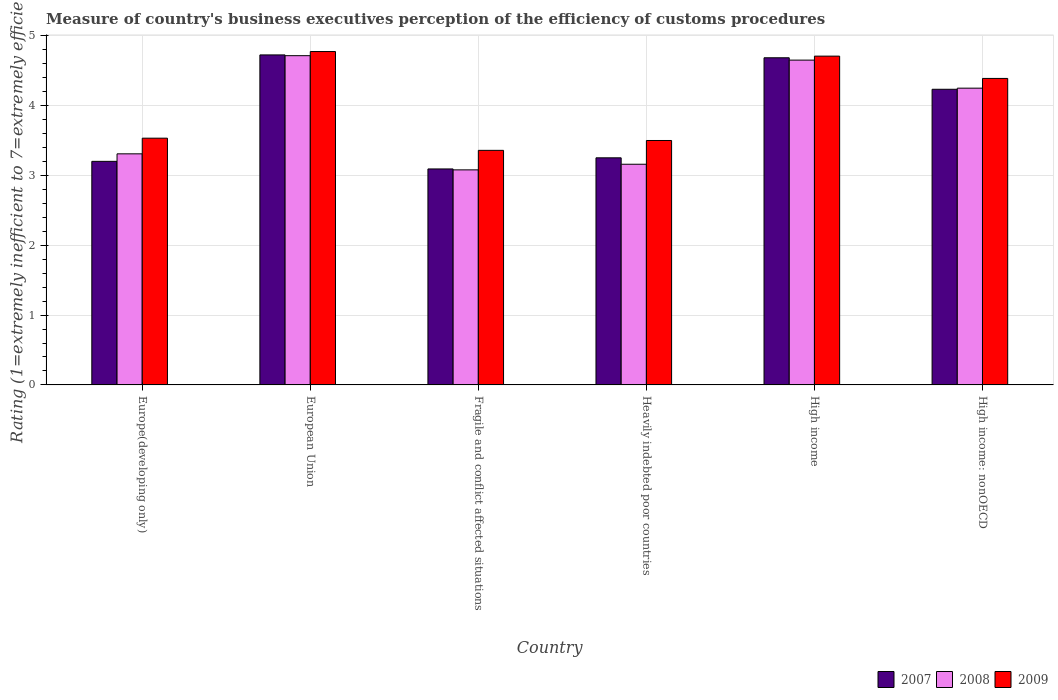How many groups of bars are there?
Make the answer very short. 6. Are the number of bars per tick equal to the number of legend labels?
Your answer should be very brief. Yes. Are the number of bars on each tick of the X-axis equal?
Provide a short and direct response. Yes. How many bars are there on the 4th tick from the right?
Make the answer very short. 3. What is the label of the 3rd group of bars from the left?
Offer a terse response. Fragile and conflict affected situations. In how many cases, is the number of bars for a given country not equal to the number of legend labels?
Keep it short and to the point. 0. What is the rating of the efficiency of customs procedure in 2009 in Europe(developing only)?
Provide a succinct answer. 3.53. Across all countries, what is the maximum rating of the efficiency of customs procedure in 2009?
Your answer should be compact. 4.77. Across all countries, what is the minimum rating of the efficiency of customs procedure in 2007?
Ensure brevity in your answer.  3.09. In which country was the rating of the efficiency of customs procedure in 2009 maximum?
Provide a succinct answer. European Union. In which country was the rating of the efficiency of customs procedure in 2009 minimum?
Give a very brief answer. Fragile and conflict affected situations. What is the total rating of the efficiency of customs procedure in 2007 in the graph?
Keep it short and to the point. 23.19. What is the difference between the rating of the efficiency of customs procedure in 2009 in Europe(developing only) and that in High income: nonOECD?
Provide a short and direct response. -0.86. What is the difference between the rating of the efficiency of customs procedure in 2009 in High income and the rating of the efficiency of customs procedure in 2007 in European Union?
Provide a succinct answer. -0.02. What is the average rating of the efficiency of customs procedure in 2007 per country?
Ensure brevity in your answer.  3.86. What is the difference between the rating of the efficiency of customs procedure of/in 2008 and rating of the efficiency of customs procedure of/in 2007 in High income: nonOECD?
Your answer should be very brief. 0.02. What is the ratio of the rating of the efficiency of customs procedure in 2008 in Europe(developing only) to that in European Union?
Provide a short and direct response. 0.7. Is the difference between the rating of the efficiency of customs procedure in 2008 in Europe(developing only) and Fragile and conflict affected situations greater than the difference between the rating of the efficiency of customs procedure in 2007 in Europe(developing only) and Fragile and conflict affected situations?
Make the answer very short. Yes. What is the difference between the highest and the second highest rating of the efficiency of customs procedure in 2007?
Make the answer very short. 0.04. What is the difference between the highest and the lowest rating of the efficiency of customs procedure in 2008?
Your response must be concise. 1.64. In how many countries, is the rating of the efficiency of customs procedure in 2009 greater than the average rating of the efficiency of customs procedure in 2009 taken over all countries?
Give a very brief answer. 3. What does the 2nd bar from the right in Fragile and conflict affected situations represents?
Offer a terse response. 2008. Is it the case that in every country, the sum of the rating of the efficiency of customs procedure in 2008 and rating of the efficiency of customs procedure in 2009 is greater than the rating of the efficiency of customs procedure in 2007?
Your answer should be compact. Yes. How many bars are there?
Keep it short and to the point. 18. Are all the bars in the graph horizontal?
Offer a terse response. No. What is the difference between two consecutive major ticks on the Y-axis?
Provide a short and direct response. 1. Does the graph contain any zero values?
Provide a succinct answer. No. Does the graph contain grids?
Give a very brief answer. Yes. How many legend labels are there?
Provide a short and direct response. 3. How are the legend labels stacked?
Provide a succinct answer. Horizontal. What is the title of the graph?
Make the answer very short. Measure of country's business executives perception of the efficiency of customs procedures. What is the label or title of the X-axis?
Your response must be concise. Country. What is the label or title of the Y-axis?
Offer a terse response. Rating (1=extremely inefficient to 7=extremely efficient). What is the Rating (1=extremely inefficient to 7=extremely efficient) of 2007 in Europe(developing only)?
Give a very brief answer. 3.2. What is the Rating (1=extremely inefficient to 7=extremely efficient) of 2008 in Europe(developing only)?
Make the answer very short. 3.31. What is the Rating (1=extremely inefficient to 7=extremely efficient) of 2009 in Europe(developing only)?
Provide a short and direct response. 3.53. What is the Rating (1=extremely inefficient to 7=extremely efficient) in 2007 in European Union?
Your answer should be very brief. 4.73. What is the Rating (1=extremely inefficient to 7=extremely efficient) of 2008 in European Union?
Give a very brief answer. 4.71. What is the Rating (1=extremely inefficient to 7=extremely efficient) of 2009 in European Union?
Make the answer very short. 4.77. What is the Rating (1=extremely inefficient to 7=extremely efficient) of 2007 in Fragile and conflict affected situations?
Your response must be concise. 3.09. What is the Rating (1=extremely inefficient to 7=extremely efficient) of 2008 in Fragile and conflict affected situations?
Ensure brevity in your answer.  3.08. What is the Rating (1=extremely inefficient to 7=extremely efficient) of 2009 in Fragile and conflict affected situations?
Your answer should be very brief. 3.36. What is the Rating (1=extremely inefficient to 7=extremely efficient) in 2007 in Heavily indebted poor countries?
Make the answer very short. 3.25. What is the Rating (1=extremely inefficient to 7=extremely efficient) in 2008 in Heavily indebted poor countries?
Offer a terse response. 3.16. What is the Rating (1=extremely inefficient to 7=extremely efficient) in 2009 in Heavily indebted poor countries?
Provide a short and direct response. 3.5. What is the Rating (1=extremely inefficient to 7=extremely efficient) of 2007 in High income?
Provide a succinct answer. 4.68. What is the Rating (1=extremely inefficient to 7=extremely efficient) of 2008 in High income?
Make the answer very short. 4.65. What is the Rating (1=extremely inefficient to 7=extremely efficient) of 2009 in High income?
Keep it short and to the point. 4.71. What is the Rating (1=extremely inefficient to 7=extremely efficient) in 2007 in High income: nonOECD?
Make the answer very short. 4.23. What is the Rating (1=extremely inefficient to 7=extremely efficient) in 2008 in High income: nonOECD?
Give a very brief answer. 4.25. What is the Rating (1=extremely inefficient to 7=extremely efficient) of 2009 in High income: nonOECD?
Make the answer very short. 4.39. Across all countries, what is the maximum Rating (1=extremely inefficient to 7=extremely efficient) of 2007?
Make the answer very short. 4.73. Across all countries, what is the maximum Rating (1=extremely inefficient to 7=extremely efficient) in 2008?
Your answer should be very brief. 4.71. Across all countries, what is the maximum Rating (1=extremely inefficient to 7=extremely efficient) of 2009?
Your response must be concise. 4.77. Across all countries, what is the minimum Rating (1=extremely inefficient to 7=extremely efficient) in 2007?
Keep it short and to the point. 3.09. Across all countries, what is the minimum Rating (1=extremely inefficient to 7=extremely efficient) of 2008?
Ensure brevity in your answer.  3.08. Across all countries, what is the minimum Rating (1=extremely inefficient to 7=extremely efficient) in 2009?
Give a very brief answer. 3.36. What is the total Rating (1=extremely inefficient to 7=extremely efficient) of 2007 in the graph?
Give a very brief answer. 23.19. What is the total Rating (1=extremely inefficient to 7=extremely efficient) of 2008 in the graph?
Your answer should be very brief. 23.16. What is the total Rating (1=extremely inefficient to 7=extremely efficient) of 2009 in the graph?
Offer a very short reply. 24.26. What is the difference between the Rating (1=extremely inefficient to 7=extremely efficient) of 2007 in Europe(developing only) and that in European Union?
Offer a terse response. -1.52. What is the difference between the Rating (1=extremely inefficient to 7=extremely efficient) of 2008 in Europe(developing only) and that in European Union?
Offer a terse response. -1.41. What is the difference between the Rating (1=extremely inefficient to 7=extremely efficient) in 2009 in Europe(developing only) and that in European Union?
Offer a terse response. -1.24. What is the difference between the Rating (1=extremely inefficient to 7=extremely efficient) in 2007 in Europe(developing only) and that in Fragile and conflict affected situations?
Offer a very short reply. 0.11. What is the difference between the Rating (1=extremely inefficient to 7=extremely efficient) of 2008 in Europe(developing only) and that in Fragile and conflict affected situations?
Provide a short and direct response. 0.23. What is the difference between the Rating (1=extremely inefficient to 7=extremely efficient) of 2009 in Europe(developing only) and that in Fragile and conflict affected situations?
Provide a short and direct response. 0.17. What is the difference between the Rating (1=extremely inefficient to 7=extremely efficient) of 2007 in Europe(developing only) and that in Heavily indebted poor countries?
Keep it short and to the point. -0.05. What is the difference between the Rating (1=extremely inefficient to 7=extremely efficient) in 2008 in Europe(developing only) and that in Heavily indebted poor countries?
Provide a short and direct response. 0.15. What is the difference between the Rating (1=extremely inefficient to 7=extremely efficient) in 2009 in Europe(developing only) and that in Heavily indebted poor countries?
Provide a short and direct response. 0.03. What is the difference between the Rating (1=extremely inefficient to 7=extremely efficient) of 2007 in Europe(developing only) and that in High income?
Give a very brief answer. -1.48. What is the difference between the Rating (1=extremely inefficient to 7=extremely efficient) in 2008 in Europe(developing only) and that in High income?
Offer a very short reply. -1.34. What is the difference between the Rating (1=extremely inefficient to 7=extremely efficient) of 2009 in Europe(developing only) and that in High income?
Your answer should be very brief. -1.18. What is the difference between the Rating (1=extremely inefficient to 7=extremely efficient) of 2007 in Europe(developing only) and that in High income: nonOECD?
Ensure brevity in your answer.  -1.03. What is the difference between the Rating (1=extremely inefficient to 7=extremely efficient) in 2008 in Europe(developing only) and that in High income: nonOECD?
Your answer should be very brief. -0.94. What is the difference between the Rating (1=extremely inefficient to 7=extremely efficient) of 2009 in Europe(developing only) and that in High income: nonOECD?
Make the answer very short. -0.86. What is the difference between the Rating (1=extremely inefficient to 7=extremely efficient) of 2007 in European Union and that in Fragile and conflict affected situations?
Provide a short and direct response. 1.63. What is the difference between the Rating (1=extremely inefficient to 7=extremely efficient) in 2008 in European Union and that in Fragile and conflict affected situations?
Your answer should be compact. 1.64. What is the difference between the Rating (1=extremely inefficient to 7=extremely efficient) in 2009 in European Union and that in Fragile and conflict affected situations?
Your answer should be compact. 1.41. What is the difference between the Rating (1=extremely inefficient to 7=extremely efficient) of 2007 in European Union and that in Heavily indebted poor countries?
Your answer should be compact. 1.47. What is the difference between the Rating (1=extremely inefficient to 7=extremely efficient) of 2008 in European Union and that in Heavily indebted poor countries?
Your answer should be very brief. 1.55. What is the difference between the Rating (1=extremely inefficient to 7=extremely efficient) in 2009 in European Union and that in Heavily indebted poor countries?
Your response must be concise. 1.27. What is the difference between the Rating (1=extremely inefficient to 7=extremely efficient) in 2007 in European Union and that in High income?
Your answer should be very brief. 0.04. What is the difference between the Rating (1=extremely inefficient to 7=extremely efficient) in 2008 in European Union and that in High income?
Make the answer very short. 0.06. What is the difference between the Rating (1=extremely inefficient to 7=extremely efficient) of 2009 in European Union and that in High income?
Your response must be concise. 0.07. What is the difference between the Rating (1=extremely inefficient to 7=extremely efficient) in 2007 in European Union and that in High income: nonOECD?
Give a very brief answer. 0.49. What is the difference between the Rating (1=extremely inefficient to 7=extremely efficient) in 2008 in European Union and that in High income: nonOECD?
Provide a short and direct response. 0.47. What is the difference between the Rating (1=extremely inefficient to 7=extremely efficient) in 2009 in European Union and that in High income: nonOECD?
Keep it short and to the point. 0.39. What is the difference between the Rating (1=extremely inefficient to 7=extremely efficient) of 2007 in Fragile and conflict affected situations and that in Heavily indebted poor countries?
Offer a terse response. -0.16. What is the difference between the Rating (1=extremely inefficient to 7=extremely efficient) in 2008 in Fragile and conflict affected situations and that in Heavily indebted poor countries?
Ensure brevity in your answer.  -0.08. What is the difference between the Rating (1=extremely inefficient to 7=extremely efficient) of 2009 in Fragile and conflict affected situations and that in Heavily indebted poor countries?
Keep it short and to the point. -0.14. What is the difference between the Rating (1=extremely inefficient to 7=extremely efficient) in 2007 in Fragile and conflict affected situations and that in High income?
Give a very brief answer. -1.59. What is the difference between the Rating (1=extremely inefficient to 7=extremely efficient) in 2008 in Fragile and conflict affected situations and that in High income?
Provide a short and direct response. -1.57. What is the difference between the Rating (1=extremely inefficient to 7=extremely efficient) of 2009 in Fragile and conflict affected situations and that in High income?
Offer a terse response. -1.35. What is the difference between the Rating (1=extremely inefficient to 7=extremely efficient) in 2007 in Fragile and conflict affected situations and that in High income: nonOECD?
Provide a short and direct response. -1.14. What is the difference between the Rating (1=extremely inefficient to 7=extremely efficient) in 2008 in Fragile and conflict affected situations and that in High income: nonOECD?
Your answer should be very brief. -1.17. What is the difference between the Rating (1=extremely inefficient to 7=extremely efficient) of 2009 in Fragile and conflict affected situations and that in High income: nonOECD?
Keep it short and to the point. -1.03. What is the difference between the Rating (1=extremely inefficient to 7=extremely efficient) of 2007 in Heavily indebted poor countries and that in High income?
Ensure brevity in your answer.  -1.43. What is the difference between the Rating (1=extremely inefficient to 7=extremely efficient) in 2008 in Heavily indebted poor countries and that in High income?
Give a very brief answer. -1.49. What is the difference between the Rating (1=extremely inefficient to 7=extremely efficient) of 2009 in Heavily indebted poor countries and that in High income?
Keep it short and to the point. -1.21. What is the difference between the Rating (1=extremely inefficient to 7=extremely efficient) of 2007 in Heavily indebted poor countries and that in High income: nonOECD?
Make the answer very short. -0.98. What is the difference between the Rating (1=extremely inefficient to 7=extremely efficient) of 2008 in Heavily indebted poor countries and that in High income: nonOECD?
Keep it short and to the point. -1.09. What is the difference between the Rating (1=extremely inefficient to 7=extremely efficient) of 2009 in Heavily indebted poor countries and that in High income: nonOECD?
Your answer should be very brief. -0.89. What is the difference between the Rating (1=extremely inefficient to 7=extremely efficient) of 2007 in High income and that in High income: nonOECD?
Make the answer very short. 0.45. What is the difference between the Rating (1=extremely inefficient to 7=extremely efficient) in 2008 in High income and that in High income: nonOECD?
Keep it short and to the point. 0.4. What is the difference between the Rating (1=extremely inefficient to 7=extremely efficient) of 2009 in High income and that in High income: nonOECD?
Give a very brief answer. 0.32. What is the difference between the Rating (1=extremely inefficient to 7=extremely efficient) of 2007 in Europe(developing only) and the Rating (1=extremely inefficient to 7=extremely efficient) of 2008 in European Union?
Provide a short and direct response. -1.51. What is the difference between the Rating (1=extremely inefficient to 7=extremely efficient) in 2007 in Europe(developing only) and the Rating (1=extremely inefficient to 7=extremely efficient) in 2009 in European Union?
Make the answer very short. -1.57. What is the difference between the Rating (1=extremely inefficient to 7=extremely efficient) of 2008 in Europe(developing only) and the Rating (1=extremely inefficient to 7=extremely efficient) of 2009 in European Union?
Your response must be concise. -1.46. What is the difference between the Rating (1=extremely inefficient to 7=extremely efficient) in 2007 in Europe(developing only) and the Rating (1=extremely inefficient to 7=extremely efficient) in 2008 in Fragile and conflict affected situations?
Make the answer very short. 0.12. What is the difference between the Rating (1=extremely inefficient to 7=extremely efficient) in 2007 in Europe(developing only) and the Rating (1=extremely inefficient to 7=extremely efficient) in 2009 in Fragile and conflict affected situations?
Provide a succinct answer. -0.16. What is the difference between the Rating (1=extremely inefficient to 7=extremely efficient) in 2008 in Europe(developing only) and the Rating (1=extremely inefficient to 7=extremely efficient) in 2009 in Fragile and conflict affected situations?
Keep it short and to the point. -0.05. What is the difference between the Rating (1=extremely inefficient to 7=extremely efficient) in 2007 in Europe(developing only) and the Rating (1=extremely inefficient to 7=extremely efficient) in 2008 in Heavily indebted poor countries?
Provide a short and direct response. 0.04. What is the difference between the Rating (1=extremely inefficient to 7=extremely efficient) in 2007 in Europe(developing only) and the Rating (1=extremely inefficient to 7=extremely efficient) in 2009 in Heavily indebted poor countries?
Offer a very short reply. -0.3. What is the difference between the Rating (1=extremely inefficient to 7=extremely efficient) in 2008 in Europe(developing only) and the Rating (1=extremely inefficient to 7=extremely efficient) in 2009 in Heavily indebted poor countries?
Provide a short and direct response. -0.19. What is the difference between the Rating (1=extremely inefficient to 7=extremely efficient) in 2007 in Europe(developing only) and the Rating (1=extremely inefficient to 7=extremely efficient) in 2008 in High income?
Offer a terse response. -1.45. What is the difference between the Rating (1=extremely inefficient to 7=extremely efficient) in 2007 in Europe(developing only) and the Rating (1=extremely inefficient to 7=extremely efficient) in 2009 in High income?
Provide a short and direct response. -1.51. What is the difference between the Rating (1=extremely inefficient to 7=extremely efficient) of 2008 in Europe(developing only) and the Rating (1=extremely inefficient to 7=extremely efficient) of 2009 in High income?
Keep it short and to the point. -1.4. What is the difference between the Rating (1=extremely inefficient to 7=extremely efficient) of 2007 in Europe(developing only) and the Rating (1=extremely inefficient to 7=extremely efficient) of 2008 in High income: nonOECD?
Provide a succinct answer. -1.05. What is the difference between the Rating (1=extremely inefficient to 7=extremely efficient) in 2007 in Europe(developing only) and the Rating (1=extremely inefficient to 7=extremely efficient) in 2009 in High income: nonOECD?
Your answer should be very brief. -1.19. What is the difference between the Rating (1=extremely inefficient to 7=extremely efficient) in 2008 in Europe(developing only) and the Rating (1=extremely inefficient to 7=extremely efficient) in 2009 in High income: nonOECD?
Offer a very short reply. -1.08. What is the difference between the Rating (1=extremely inefficient to 7=extremely efficient) of 2007 in European Union and the Rating (1=extremely inefficient to 7=extremely efficient) of 2008 in Fragile and conflict affected situations?
Your answer should be compact. 1.65. What is the difference between the Rating (1=extremely inefficient to 7=extremely efficient) in 2007 in European Union and the Rating (1=extremely inefficient to 7=extremely efficient) in 2009 in Fragile and conflict affected situations?
Your response must be concise. 1.37. What is the difference between the Rating (1=extremely inefficient to 7=extremely efficient) in 2008 in European Union and the Rating (1=extremely inefficient to 7=extremely efficient) in 2009 in Fragile and conflict affected situations?
Your answer should be compact. 1.36. What is the difference between the Rating (1=extremely inefficient to 7=extremely efficient) of 2007 in European Union and the Rating (1=extremely inefficient to 7=extremely efficient) of 2008 in Heavily indebted poor countries?
Offer a very short reply. 1.57. What is the difference between the Rating (1=extremely inefficient to 7=extremely efficient) of 2007 in European Union and the Rating (1=extremely inefficient to 7=extremely efficient) of 2009 in Heavily indebted poor countries?
Your answer should be very brief. 1.23. What is the difference between the Rating (1=extremely inefficient to 7=extremely efficient) in 2008 in European Union and the Rating (1=extremely inefficient to 7=extremely efficient) in 2009 in Heavily indebted poor countries?
Offer a very short reply. 1.21. What is the difference between the Rating (1=extremely inefficient to 7=extremely efficient) of 2007 in European Union and the Rating (1=extremely inefficient to 7=extremely efficient) of 2008 in High income?
Your answer should be very brief. 0.07. What is the difference between the Rating (1=extremely inefficient to 7=extremely efficient) in 2007 in European Union and the Rating (1=extremely inefficient to 7=extremely efficient) in 2009 in High income?
Your response must be concise. 0.02. What is the difference between the Rating (1=extremely inefficient to 7=extremely efficient) of 2008 in European Union and the Rating (1=extremely inefficient to 7=extremely efficient) of 2009 in High income?
Keep it short and to the point. 0.01. What is the difference between the Rating (1=extremely inefficient to 7=extremely efficient) in 2007 in European Union and the Rating (1=extremely inefficient to 7=extremely efficient) in 2008 in High income: nonOECD?
Provide a succinct answer. 0.48. What is the difference between the Rating (1=extremely inefficient to 7=extremely efficient) in 2007 in European Union and the Rating (1=extremely inefficient to 7=extremely efficient) in 2009 in High income: nonOECD?
Your answer should be compact. 0.34. What is the difference between the Rating (1=extremely inefficient to 7=extremely efficient) in 2008 in European Union and the Rating (1=extremely inefficient to 7=extremely efficient) in 2009 in High income: nonOECD?
Offer a very short reply. 0.33. What is the difference between the Rating (1=extremely inefficient to 7=extremely efficient) of 2007 in Fragile and conflict affected situations and the Rating (1=extremely inefficient to 7=extremely efficient) of 2008 in Heavily indebted poor countries?
Ensure brevity in your answer.  -0.07. What is the difference between the Rating (1=extremely inefficient to 7=extremely efficient) of 2007 in Fragile and conflict affected situations and the Rating (1=extremely inefficient to 7=extremely efficient) of 2009 in Heavily indebted poor countries?
Provide a succinct answer. -0.41. What is the difference between the Rating (1=extremely inefficient to 7=extremely efficient) in 2008 in Fragile and conflict affected situations and the Rating (1=extremely inefficient to 7=extremely efficient) in 2009 in Heavily indebted poor countries?
Provide a succinct answer. -0.42. What is the difference between the Rating (1=extremely inefficient to 7=extremely efficient) in 2007 in Fragile and conflict affected situations and the Rating (1=extremely inefficient to 7=extremely efficient) in 2008 in High income?
Provide a short and direct response. -1.56. What is the difference between the Rating (1=extremely inefficient to 7=extremely efficient) of 2007 in Fragile and conflict affected situations and the Rating (1=extremely inefficient to 7=extremely efficient) of 2009 in High income?
Ensure brevity in your answer.  -1.62. What is the difference between the Rating (1=extremely inefficient to 7=extremely efficient) of 2008 in Fragile and conflict affected situations and the Rating (1=extremely inefficient to 7=extremely efficient) of 2009 in High income?
Your answer should be compact. -1.63. What is the difference between the Rating (1=extremely inefficient to 7=extremely efficient) in 2007 in Fragile and conflict affected situations and the Rating (1=extremely inefficient to 7=extremely efficient) in 2008 in High income: nonOECD?
Ensure brevity in your answer.  -1.16. What is the difference between the Rating (1=extremely inefficient to 7=extremely efficient) of 2007 in Fragile and conflict affected situations and the Rating (1=extremely inefficient to 7=extremely efficient) of 2009 in High income: nonOECD?
Your answer should be very brief. -1.3. What is the difference between the Rating (1=extremely inefficient to 7=extremely efficient) in 2008 in Fragile and conflict affected situations and the Rating (1=extremely inefficient to 7=extremely efficient) in 2009 in High income: nonOECD?
Offer a terse response. -1.31. What is the difference between the Rating (1=extremely inefficient to 7=extremely efficient) of 2007 in Heavily indebted poor countries and the Rating (1=extremely inefficient to 7=extremely efficient) of 2008 in High income?
Make the answer very short. -1.4. What is the difference between the Rating (1=extremely inefficient to 7=extremely efficient) of 2007 in Heavily indebted poor countries and the Rating (1=extremely inefficient to 7=extremely efficient) of 2009 in High income?
Your response must be concise. -1.46. What is the difference between the Rating (1=extremely inefficient to 7=extremely efficient) of 2008 in Heavily indebted poor countries and the Rating (1=extremely inefficient to 7=extremely efficient) of 2009 in High income?
Offer a terse response. -1.55. What is the difference between the Rating (1=extremely inefficient to 7=extremely efficient) of 2007 in Heavily indebted poor countries and the Rating (1=extremely inefficient to 7=extremely efficient) of 2008 in High income: nonOECD?
Keep it short and to the point. -1. What is the difference between the Rating (1=extremely inefficient to 7=extremely efficient) of 2007 in Heavily indebted poor countries and the Rating (1=extremely inefficient to 7=extremely efficient) of 2009 in High income: nonOECD?
Your answer should be very brief. -1.14. What is the difference between the Rating (1=extremely inefficient to 7=extremely efficient) in 2008 in Heavily indebted poor countries and the Rating (1=extremely inefficient to 7=extremely efficient) in 2009 in High income: nonOECD?
Offer a very short reply. -1.23. What is the difference between the Rating (1=extremely inefficient to 7=extremely efficient) in 2007 in High income and the Rating (1=extremely inefficient to 7=extremely efficient) in 2008 in High income: nonOECD?
Make the answer very short. 0.43. What is the difference between the Rating (1=extremely inefficient to 7=extremely efficient) in 2007 in High income and the Rating (1=extremely inefficient to 7=extremely efficient) in 2009 in High income: nonOECD?
Your answer should be very brief. 0.3. What is the difference between the Rating (1=extremely inefficient to 7=extremely efficient) of 2008 in High income and the Rating (1=extremely inefficient to 7=extremely efficient) of 2009 in High income: nonOECD?
Keep it short and to the point. 0.26. What is the average Rating (1=extremely inefficient to 7=extremely efficient) of 2007 per country?
Your response must be concise. 3.86. What is the average Rating (1=extremely inefficient to 7=extremely efficient) of 2008 per country?
Your answer should be very brief. 3.86. What is the average Rating (1=extremely inefficient to 7=extremely efficient) of 2009 per country?
Give a very brief answer. 4.04. What is the difference between the Rating (1=extremely inefficient to 7=extremely efficient) of 2007 and Rating (1=extremely inefficient to 7=extremely efficient) of 2008 in Europe(developing only)?
Keep it short and to the point. -0.11. What is the difference between the Rating (1=extremely inefficient to 7=extremely efficient) in 2007 and Rating (1=extremely inefficient to 7=extremely efficient) in 2009 in Europe(developing only)?
Give a very brief answer. -0.33. What is the difference between the Rating (1=extremely inefficient to 7=extremely efficient) in 2008 and Rating (1=extremely inefficient to 7=extremely efficient) in 2009 in Europe(developing only)?
Provide a short and direct response. -0.22. What is the difference between the Rating (1=extremely inefficient to 7=extremely efficient) of 2007 and Rating (1=extremely inefficient to 7=extremely efficient) of 2008 in European Union?
Provide a short and direct response. 0.01. What is the difference between the Rating (1=extremely inefficient to 7=extremely efficient) in 2007 and Rating (1=extremely inefficient to 7=extremely efficient) in 2009 in European Union?
Ensure brevity in your answer.  -0.05. What is the difference between the Rating (1=extremely inefficient to 7=extremely efficient) in 2008 and Rating (1=extremely inefficient to 7=extremely efficient) in 2009 in European Union?
Provide a short and direct response. -0.06. What is the difference between the Rating (1=extremely inefficient to 7=extremely efficient) in 2007 and Rating (1=extremely inefficient to 7=extremely efficient) in 2008 in Fragile and conflict affected situations?
Your answer should be very brief. 0.01. What is the difference between the Rating (1=extremely inefficient to 7=extremely efficient) of 2007 and Rating (1=extremely inefficient to 7=extremely efficient) of 2009 in Fragile and conflict affected situations?
Your answer should be compact. -0.27. What is the difference between the Rating (1=extremely inefficient to 7=extremely efficient) of 2008 and Rating (1=extremely inefficient to 7=extremely efficient) of 2009 in Fragile and conflict affected situations?
Offer a very short reply. -0.28. What is the difference between the Rating (1=extremely inefficient to 7=extremely efficient) in 2007 and Rating (1=extremely inefficient to 7=extremely efficient) in 2008 in Heavily indebted poor countries?
Provide a succinct answer. 0.09. What is the difference between the Rating (1=extremely inefficient to 7=extremely efficient) in 2007 and Rating (1=extremely inefficient to 7=extremely efficient) in 2009 in Heavily indebted poor countries?
Your answer should be compact. -0.25. What is the difference between the Rating (1=extremely inefficient to 7=extremely efficient) in 2008 and Rating (1=extremely inefficient to 7=extremely efficient) in 2009 in Heavily indebted poor countries?
Keep it short and to the point. -0.34. What is the difference between the Rating (1=extremely inefficient to 7=extremely efficient) in 2007 and Rating (1=extremely inefficient to 7=extremely efficient) in 2008 in High income?
Give a very brief answer. 0.03. What is the difference between the Rating (1=extremely inefficient to 7=extremely efficient) of 2007 and Rating (1=extremely inefficient to 7=extremely efficient) of 2009 in High income?
Keep it short and to the point. -0.02. What is the difference between the Rating (1=extremely inefficient to 7=extremely efficient) in 2008 and Rating (1=extremely inefficient to 7=extremely efficient) in 2009 in High income?
Your answer should be compact. -0.06. What is the difference between the Rating (1=extremely inefficient to 7=extremely efficient) in 2007 and Rating (1=extremely inefficient to 7=extremely efficient) in 2008 in High income: nonOECD?
Provide a succinct answer. -0.02. What is the difference between the Rating (1=extremely inefficient to 7=extremely efficient) of 2007 and Rating (1=extremely inefficient to 7=extremely efficient) of 2009 in High income: nonOECD?
Your answer should be very brief. -0.16. What is the difference between the Rating (1=extremely inefficient to 7=extremely efficient) in 2008 and Rating (1=extremely inefficient to 7=extremely efficient) in 2009 in High income: nonOECD?
Your response must be concise. -0.14. What is the ratio of the Rating (1=extremely inefficient to 7=extremely efficient) of 2007 in Europe(developing only) to that in European Union?
Your answer should be very brief. 0.68. What is the ratio of the Rating (1=extremely inefficient to 7=extremely efficient) of 2008 in Europe(developing only) to that in European Union?
Keep it short and to the point. 0.7. What is the ratio of the Rating (1=extremely inefficient to 7=extremely efficient) in 2009 in Europe(developing only) to that in European Union?
Your answer should be compact. 0.74. What is the ratio of the Rating (1=extremely inefficient to 7=extremely efficient) of 2007 in Europe(developing only) to that in Fragile and conflict affected situations?
Offer a terse response. 1.04. What is the ratio of the Rating (1=extremely inefficient to 7=extremely efficient) of 2008 in Europe(developing only) to that in Fragile and conflict affected situations?
Your answer should be compact. 1.07. What is the ratio of the Rating (1=extremely inefficient to 7=extremely efficient) of 2009 in Europe(developing only) to that in Fragile and conflict affected situations?
Your answer should be very brief. 1.05. What is the ratio of the Rating (1=extremely inefficient to 7=extremely efficient) in 2007 in Europe(developing only) to that in Heavily indebted poor countries?
Make the answer very short. 0.98. What is the ratio of the Rating (1=extremely inefficient to 7=extremely efficient) in 2008 in Europe(developing only) to that in Heavily indebted poor countries?
Give a very brief answer. 1.05. What is the ratio of the Rating (1=extremely inefficient to 7=extremely efficient) in 2009 in Europe(developing only) to that in Heavily indebted poor countries?
Keep it short and to the point. 1.01. What is the ratio of the Rating (1=extremely inefficient to 7=extremely efficient) in 2007 in Europe(developing only) to that in High income?
Provide a short and direct response. 0.68. What is the ratio of the Rating (1=extremely inefficient to 7=extremely efficient) of 2008 in Europe(developing only) to that in High income?
Make the answer very short. 0.71. What is the ratio of the Rating (1=extremely inefficient to 7=extremely efficient) in 2009 in Europe(developing only) to that in High income?
Offer a terse response. 0.75. What is the ratio of the Rating (1=extremely inefficient to 7=extremely efficient) in 2007 in Europe(developing only) to that in High income: nonOECD?
Keep it short and to the point. 0.76. What is the ratio of the Rating (1=extremely inefficient to 7=extremely efficient) of 2008 in Europe(developing only) to that in High income: nonOECD?
Make the answer very short. 0.78. What is the ratio of the Rating (1=extremely inefficient to 7=extremely efficient) of 2009 in Europe(developing only) to that in High income: nonOECD?
Offer a terse response. 0.81. What is the ratio of the Rating (1=extremely inefficient to 7=extremely efficient) of 2007 in European Union to that in Fragile and conflict affected situations?
Make the answer very short. 1.53. What is the ratio of the Rating (1=extremely inefficient to 7=extremely efficient) in 2008 in European Union to that in Fragile and conflict affected situations?
Your answer should be compact. 1.53. What is the ratio of the Rating (1=extremely inefficient to 7=extremely efficient) of 2009 in European Union to that in Fragile and conflict affected situations?
Ensure brevity in your answer.  1.42. What is the ratio of the Rating (1=extremely inefficient to 7=extremely efficient) in 2007 in European Union to that in Heavily indebted poor countries?
Make the answer very short. 1.45. What is the ratio of the Rating (1=extremely inefficient to 7=extremely efficient) of 2008 in European Union to that in Heavily indebted poor countries?
Make the answer very short. 1.49. What is the ratio of the Rating (1=extremely inefficient to 7=extremely efficient) of 2009 in European Union to that in Heavily indebted poor countries?
Give a very brief answer. 1.36. What is the ratio of the Rating (1=extremely inefficient to 7=extremely efficient) in 2007 in European Union to that in High income?
Your response must be concise. 1.01. What is the ratio of the Rating (1=extremely inefficient to 7=extremely efficient) of 2008 in European Union to that in High income?
Keep it short and to the point. 1.01. What is the ratio of the Rating (1=extremely inefficient to 7=extremely efficient) in 2009 in European Union to that in High income?
Your response must be concise. 1.01. What is the ratio of the Rating (1=extremely inefficient to 7=extremely efficient) in 2007 in European Union to that in High income: nonOECD?
Provide a short and direct response. 1.12. What is the ratio of the Rating (1=extremely inefficient to 7=extremely efficient) in 2008 in European Union to that in High income: nonOECD?
Offer a very short reply. 1.11. What is the ratio of the Rating (1=extremely inefficient to 7=extremely efficient) in 2009 in European Union to that in High income: nonOECD?
Offer a very short reply. 1.09. What is the ratio of the Rating (1=extremely inefficient to 7=extremely efficient) in 2007 in Fragile and conflict affected situations to that in Heavily indebted poor countries?
Give a very brief answer. 0.95. What is the ratio of the Rating (1=extremely inefficient to 7=extremely efficient) in 2008 in Fragile and conflict affected situations to that in Heavily indebted poor countries?
Ensure brevity in your answer.  0.97. What is the ratio of the Rating (1=extremely inefficient to 7=extremely efficient) in 2009 in Fragile and conflict affected situations to that in Heavily indebted poor countries?
Offer a very short reply. 0.96. What is the ratio of the Rating (1=extremely inefficient to 7=extremely efficient) in 2007 in Fragile and conflict affected situations to that in High income?
Offer a very short reply. 0.66. What is the ratio of the Rating (1=extremely inefficient to 7=extremely efficient) in 2008 in Fragile and conflict affected situations to that in High income?
Keep it short and to the point. 0.66. What is the ratio of the Rating (1=extremely inefficient to 7=extremely efficient) of 2009 in Fragile and conflict affected situations to that in High income?
Keep it short and to the point. 0.71. What is the ratio of the Rating (1=extremely inefficient to 7=extremely efficient) in 2007 in Fragile and conflict affected situations to that in High income: nonOECD?
Keep it short and to the point. 0.73. What is the ratio of the Rating (1=extremely inefficient to 7=extremely efficient) in 2008 in Fragile and conflict affected situations to that in High income: nonOECD?
Make the answer very short. 0.72. What is the ratio of the Rating (1=extremely inefficient to 7=extremely efficient) of 2009 in Fragile and conflict affected situations to that in High income: nonOECD?
Your answer should be very brief. 0.77. What is the ratio of the Rating (1=extremely inefficient to 7=extremely efficient) in 2007 in Heavily indebted poor countries to that in High income?
Your answer should be very brief. 0.69. What is the ratio of the Rating (1=extremely inefficient to 7=extremely efficient) of 2008 in Heavily indebted poor countries to that in High income?
Your response must be concise. 0.68. What is the ratio of the Rating (1=extremely inefficient to 7=extremely efficient) in 2009 in Heavily indebted poor countries to that in High income?
Keep it short and to the point. 0.74. What is the ratio of the Rating (1=extremely inefficient to 7=extremely efficient) of 2007 in Heavily indebted poor countries to that in High income: nonOECD?
Provide a short and direct response. 0.77. What is the ratio of the Rating (1=extremely inefficient to 7=extremely efficient) of 2008 in Heavily indebted poor countries to that in High income: nonOECD?
Your answer should be very brief. 0.74. What is the ratio of the Rating (1=extremely inefficient to 7=extremely efficient) in 2009 in Heavily indebted poor countries to that in High income: nonOECD?
Keep it short and to the point. 0.8. What is the ratio of the Rating (1=extremely inefficient to 7=extremely efficient) in 2007 in High income to that in High income: nonOECD?
Ensure brevity in your answer.  1.11. What is the ratio of the Rating (1=extremely inefficient to 7=extremely efficient) of 2008 in High income to that in High income: nonOECD?
Your answer should be compact. 1.09. What is the ratio of the Rating (1=extremely inefficient to 7=extremely efficient) of 2009 in High income to that in High income: nonOECD?
Offer a terse response. 1.07. What is the difference between the highest and the second highest Rating (1=extremely inefficient to 7=extremely efficient) in 2007?
Ensure brevity in your answer.  0.04. What is the difference between the highest and the second highest Rating (1=extremely inefficient to 7=extremely efficient) of 2008?
Your answer should be compact. 0.06. What is the difference between the highest and the second highest Rating (1=extremely inefficient to 7=extremely efficient) in 2009?
Ensure brevity in your answer.  0.07. What is the difference between the highest and the lowest Rating (1=extremely inefficient to 7=extremely efficient) of 2007?
Provide a succinct answer. 1.63. What is the difference between the highest and the lowest Rating (1=extremely inefficient to 7=extremely efficient) in 2008?
Offer a terse response. 1.64. What is the difference between the highest and the lowest Rating (1=extremely inefficient to 7=extremely efficient) in 2009?
Ensure brevity in your answer.  1.41. 